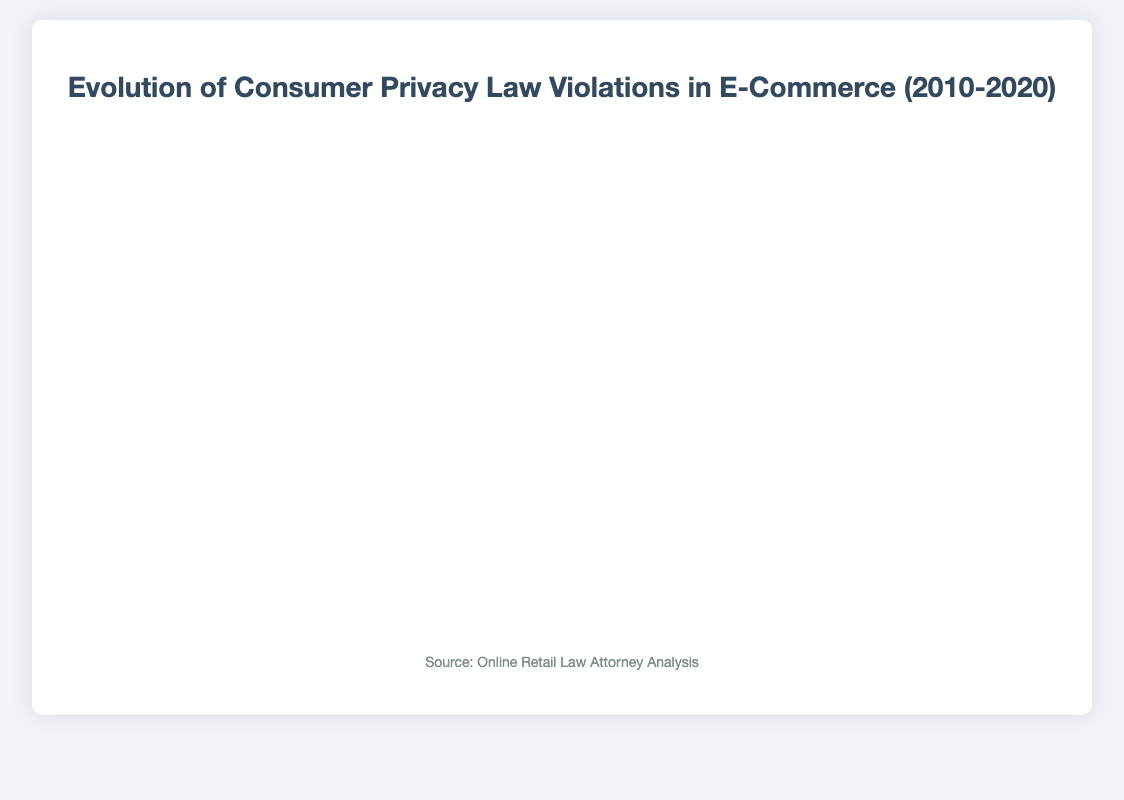What is the total number of privacy law violations from 2010 to 2020? To find the total number of violations over the period, we sum the violations for each year: 15 + 18 + 22 + 27 + 31 + 35 + 39 + 45 + 52 + 58 + 65. The sum is 407.
Answer: 407 In which year did the number of privacy law violations exceed 50? Looking at the plot, the number of violations first exceeds 50 in the year labeled 2018.
Answer: 2018 What is the difference in the number of violations between 2010 and 2020? The number of violations in 2010 is 15 and in 2020 is 65. The difference is 65 - 15 = 50.
Answer: 50 Which two consecutive years saw the largest increase in violations? By examining the year-over-year differences: 2011-2010 (3), 2012-2011 (4), 2013-2012 (5), 2014-2013 (4), 2015-2014 (4), 2016-2015 (4), 2017-2016 (6), 2018-2017 (7), 2019-2018 (6), 2020-2019 (7), we see that both 2017 to 2018 and 2019 to 2020 saw the largest increases of 7 violations each.
Answer: 2017-2018 and 2019-2020 Which major case occurred in 2016? According to the plot's tooltips or labels, the major case in 2016 was the "Vizio Smart TV Data Collection Settlement".
Answer: Vizio Smart TV Data Collection Settlement How did the number of violations change from 2015 to 2017? The number of violations in 2015 was 35, in 2016 it was 39, and in 2017 it was 45. From 2015 to 2016, the increase was 4 violations, and from 2016 to 2017, the increase was 6 violations. In total, the change from 2015 to 2017 is 45 - 35 = 10 violations.
Answer: 10 Which year experienced the smallest number of privacy law violations? Observing the plot, the year with the smallest number of violations is 2010 with 15 violations.
Answer: 2010 What average number of violations were observed from 2013 to 2017? To find the average, we add the violations between 2013 and 2017 and divide by the number of years: (27 + 31 + 35 + 39 + 45) / 5. This gives (177) / 5 = 35.4.
Answer: 35.4 